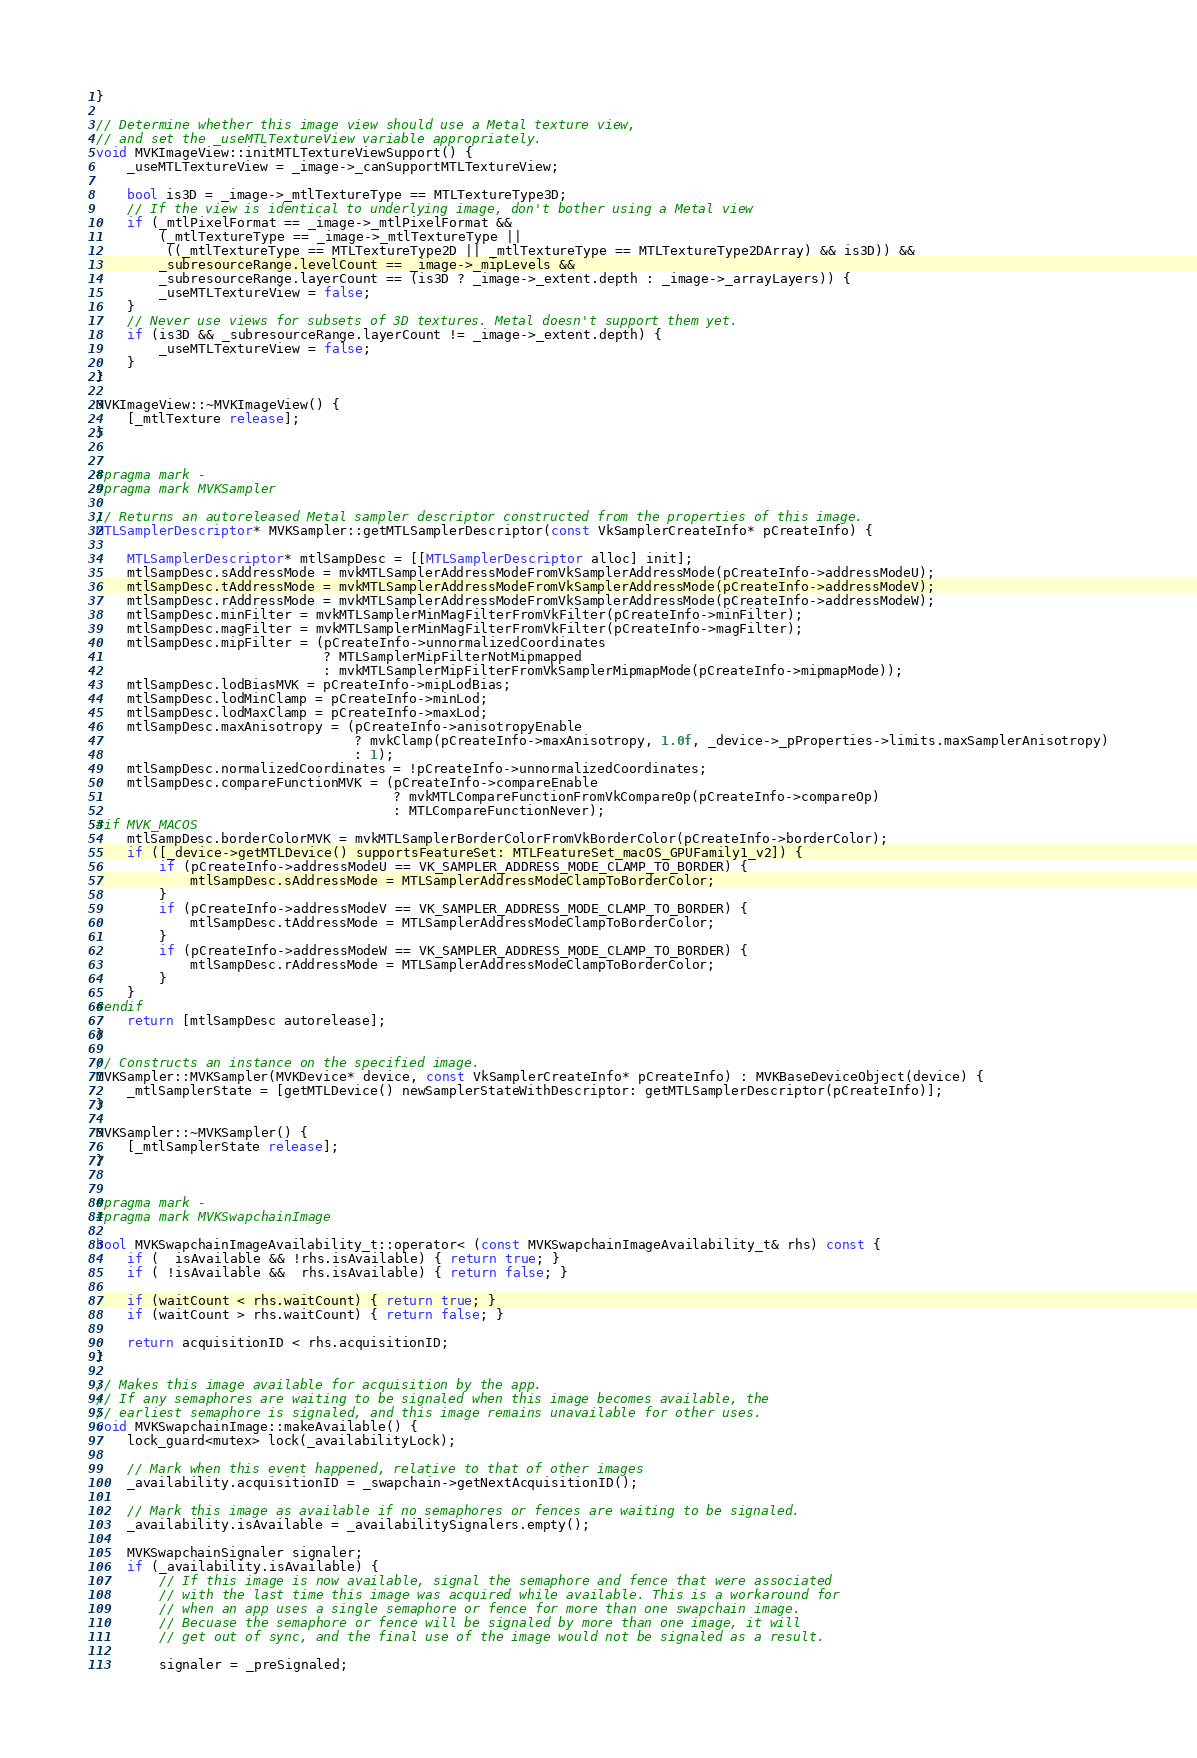<code> <loc_0><loc_0><loc_500><loc_500><_ObjectiveC_>}

// Determine whether this image view should use a Metal texture view,
// and set the _useMTLTextureView variable appropriately.
void MVKImageView::initMTLTextureViewSupport() {
	_useMTLTextureView = _image->_canSupportMTLTextureView;

	bool is3D = _image->_mtlTextureType == MTLTextureType3D;
	// If the view is identical to underlying image, don't bother using a Metal view
	if (_mtlPixelFormat == _image->_mtlPixelFormat &&
		(_mtlTextureType == _image->_mtlTextureType ||
		 ((_mtlTextureType == MTLTextureType2D || _mtlTextureType == MTLTextureType2DArray) && is3D)) &&
		_subresourceRange.levelCount == _image->_mipLevels &&
		_subresourceRange.layerCount == (is3D ? _image->_extent.depth : _image->_arrayLayers)) {
		_useMTLTextureView = false;
	}
	// Never use views for subsets of 3D textures. Metal doesn't support them yet.
	if (is3D && _subresourceRange.layerCount != _image->_extent.depth) {
		_useMTLTextureView = false;
	}
}

MVKImageView::~MVKImageView() {
	[_mtlTexture release];
}


#pragma mark -
#pragma mark MVKSampler

// Returns an autoreleased Metal sampler descriptor constructed from the properties of this image.
MTLSamplerDescriptor* MVKSampler::getMTLSamplerDescriptor(const VkSamplerCreateInfo* pCreateInfo) {

	MTLSamplerDescriptor* mtlSampDesc = [[MTLSamplerDescriptor alloc] init];
	mtlSampDesc.sAddressMode = mvkMTLSamplerAddressModeFromVkSamplerAddressMode(pCreateInfo->addressModeU);
	mtlSampDesc.tAddressMode = mvkMTLSamplerAddressModeFromVkSamplerAddressMode(pCreateInfo->addressModeV);
    mtlSampDesc.rAddressMode = mvkMTLSamplerAddressModeFromVkSamplerAddressMode(pCreateInfo->addressModeW);
	mtlSampDesc.minFilter = mvkMTLSamplerMinMagFilterFromVkFilter(pCreateInfo->minFilter);
	mtlSampDesc.magFilter = mvkMTLSamplerMinMagFilterFromVkFilter(pCreateInfo->magFilter);
    mtlSampDesc.mipFilter = (pCreateInfo->unnormalizedCoordinates
                             ? MTLSamplerMipFilterNotMipmapped
                             : mvkMTLSamplerMipFilterFromVkSamplerMipmapMode(pCreateInfo->mipmapMode));
	mtlSampDesc.lodBiasMVK = pCreateInfo->mipLodBias;
	mtlSampDesc.lodMinClamp = pCreateInfo->minLod;
	mtlSampDesc.lodMaxClamp = pCreateInfo->maxLod;
	mtlSampDesc.maxAnisotropy = (pCreateInfo->anisotropyEnable
								 ? mvkClamp(pCreateInfo->maxAnisotropy, 1.0f, _device->_pProperties->limits.maxSamplerAnisotropy)
								 : 1);
	mtlSampDesc.normalizedCoordinates = !pCreateInfo->unnormalizedCoordinates;
	mtlSampDesc.compareFunctionMVK = (pCreateInfo->compareEnable
									  ? mvkMTLCompareFunctionFromVkCompareOp(pCreateInfo->compareOp)
									  : MTLCompareFunctionNever);
#if MVK_MACOS
	mtlSampDesc.borderColorMVK = mvkMTLSamplerBorderColorFromVkBorderColor(pCreateInfo->borderColor);
	if ([_device->getMTLDevice() supportsFeatureSet: MTLFeatureSet_macOS_GPUFamily1_v2]) {
		if (pCreateInfo->addressModeU == VK_SAMPLER_ADDRESS_MODE_CLAMP_TO_BORDER) {
			mtlSampDesc.sAddressMode = MTLSamplerAddressModeClampToBorderColor;
		}
		if (pCreateInfo->addressModeV == VK_SAMPLER_ADDRESS_MODE_CLAMP_TO_BORDER) {
			mtlSampDesc.tAddressMode = MTLSamplerAddressModeClampToBorderColor;
		}
		if (pCreateInfo->addressModeW == VK_SAMPLER_ADDRESS_MODE_CLAMP_TO_BORDER) {
			mtlSampDesc.rAddressMode = MTLSamplerAddressModeClampToBorderColor;
		}
	}
#endif
	return [mtlSampDesc autorelease];
}

// Constructs an instance on the specified image.
MVKSampler::MVKSampler(MVKDevice* device, const VkSamplerCreateInfo* pCreateInfo) : MVKBaseDeviceObject(device) {
    _mtlSamplerState = [getMTLDevice() newSamplerStateWithDescriptor: getMTLSamplerDescriptor(pCreateInfo)];
}

MVKSampler::~MVKSampler() {
	[_mtlSamplerState release];
}


#pragma mark -
#pragma mark MVKSwapchainImage

bool MVKSwapchainImageAvailability_t::operator< (const MVKSwapchainImageAvailability_t& rhs) const {
	if (  isAvailable && !rhs.isAvailable) { return true; }
	if ( !isAvailable &&  rhs.isAvailable) { return false; }

	if (waitCount < rhs.waitCount) { return true; }
	if (waitCount > rhs.waitCount) { return false; }

	return acquisitionID < rhs.acquisitionID;
}

// Makes this image available for acquisition by the app.
// If any semaphores are waiting to be signaled when this image becomes available, the
// earliest semaphore is signaled, and this image remains unavailable for other uses.
void MVKSwapchainImage::makeAvailable() {
	lock_guard<mutex> lock(_availabilityLock);

	// Mark when this event happened, relative to that of other images
	_availability.acquisitionID = _swapchain->getNextAcquisitionID();

	// Mark this image as available if no semaphores or fences are waiting to be signaled.
	_availability.isAvailable = _availabilitySignalers.empty();

	MVKSwapchainSignaler signaler;
	if (_availability.isAvailable) {
		// If this image is now available, signal the semaphore and fence that were associated
		// with the last time this image was acquired while available. This is a workaround for
		// when an app uses a single semaphore or fence for more than one swapchain image.
		// Becuase the semaphore or fence will be signaled by more than one image, it will
		// get out of sync, and the final use of the image would not be signaled as a result.

		signaler = _preSignaled;</code> 